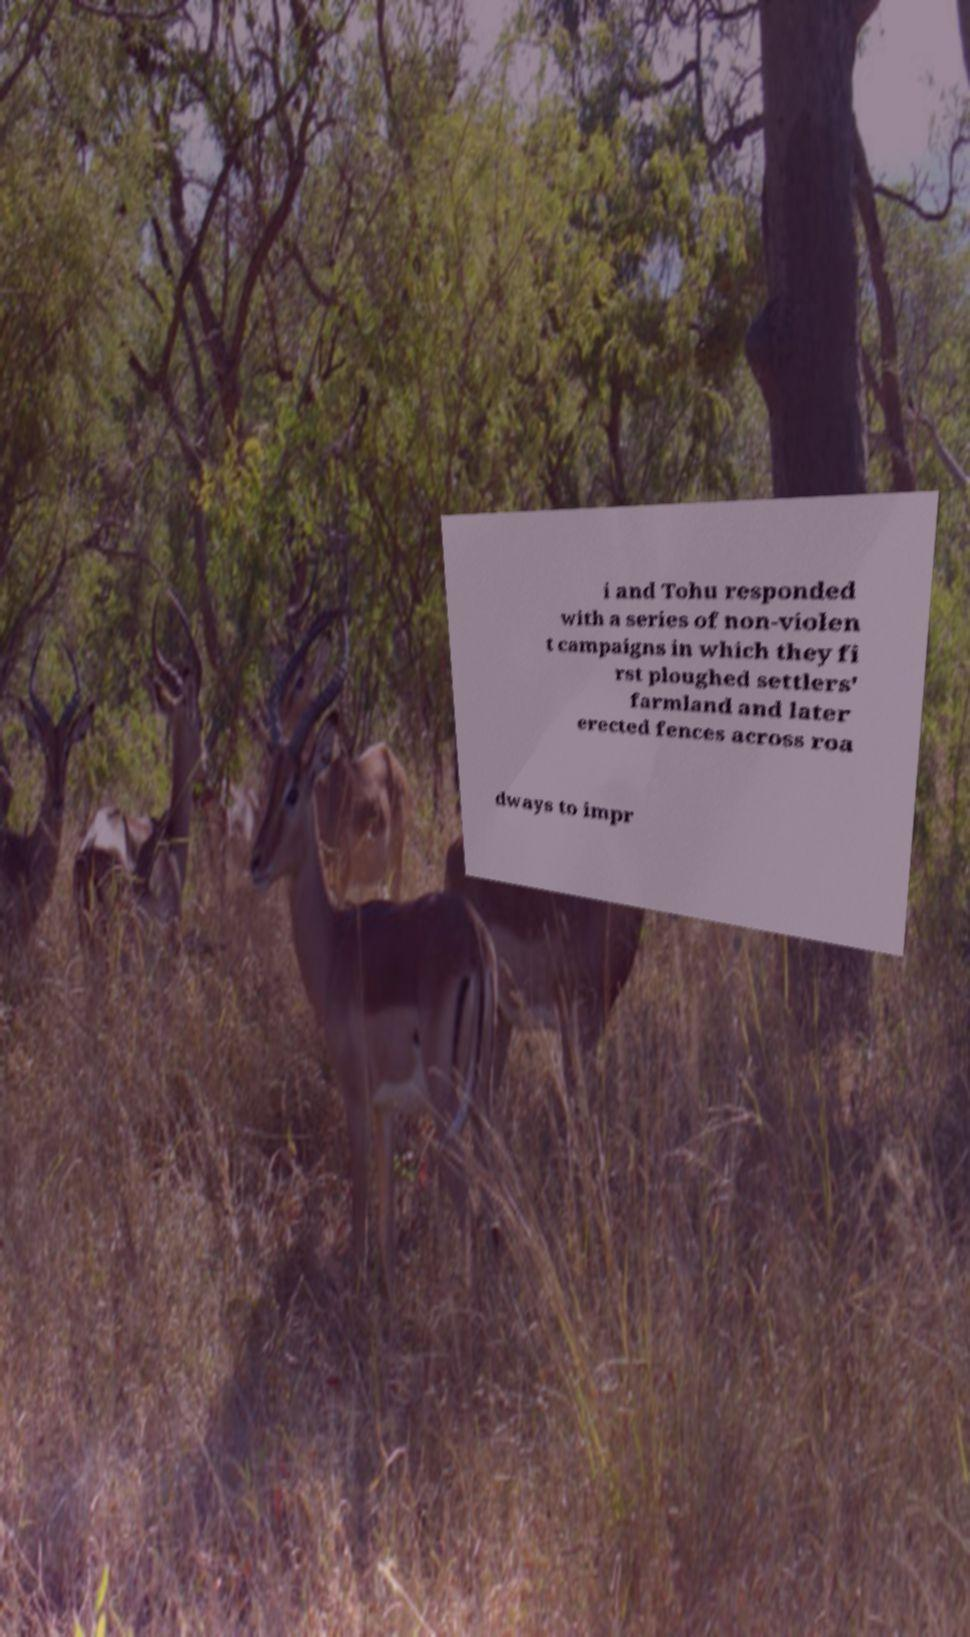I need the written content from this picture converted into text. Can you do that? i and Tohu responded with a series of non-violen t campaigns in which they fi rst ploughed settlers' farmland and later erected fences across roa dways to impr 